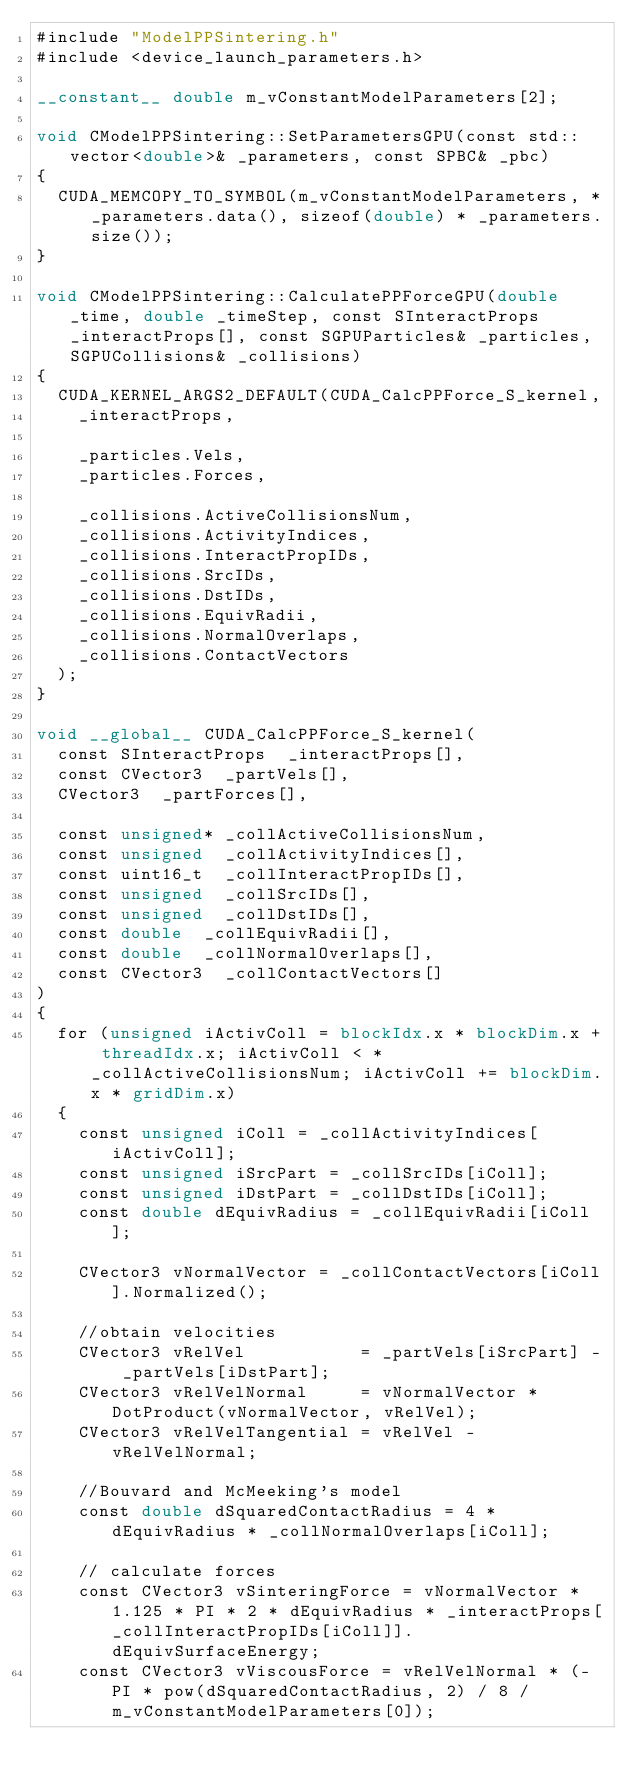Convert code to text. <code><loc_0><loc_0><loc_500><loc_500><_Cuda_>#include "ModelPPSintering.h"
#include <device_launch_parameters.h>

__constant__ double m_vConstantModelParameters[2];

void CModelPPSintering::SetParametersGPU(const std::vector<double>& _parameters, const SPBC& _pbc)
{
	CUDA_MEMCOPY_TO_SYMBOL(m_vConstantModelParameters, *_parameters.data(), sizeof(double) * _parameters.size());
}

void CModelPPSintering::CalculatePPForceGPU(double _time, double _timeStep, const SInteractProps _interactProps[], const SGPUParticles& _particles, SGPUCollisions& _collisions)
{
	CUDA_KERNEL_ARGS2_DEFAULT(CUDA_CalcPPForce_S_kernel,
		_interactProps,

		_particles.Vels,
		_particles.Forces,

		_collisions.ActiveCollisionsNum,
		_collisions.ActivityIndices,
		_collisions.InteractPropIDs,
		_collisions.SrcIDs,
		_collisions.DstIDs,
		_collisions.EquivRadii,
		_collisions.NormalOverlaps,
		_collisions.ContactVectors
	);
}

void __global__ CUDA_CalcPPForce_S_kernel(
	const SInteractProps	_interactProps[],
	const CVector3	_partVels[],
	CVector3	_partForces[],

	const unsigned*	_collActiveCollisionsNum,
	const unsigned	_collActivityIndices[],
	const uint16_t	_collInteractPropIDs[],
	const unsigned	_collSrcIDs[],
	const unsigned	_collDstIDs[],
	const double	_collEquivRadii[],
	const double	_collNormalOverlaps[],
	const CVector3  _collContactVectors[]
)
{
	for (unsigned iActivColl = blockIdx.x * blockDim.x + threadIdx.x; iActivColl < *_collActiveCollisionsNum; iActivColl += blockDim.x * gridDim.x)
	{
		const unsigned iColl = _collActivityIndices[iActivColl];
		const unsigned iSrcPart = _collSrcIDs[iColl];
		const unsigned iDstPart = _collDstIDs[iColl];
		const double dEquivRadius = _collEquivRadii[iColl];

		CVector3 vNormalVector = _collContactVectors[iColl].Normalized();

		//obtain velocities
		CVector3 vRelVel           = _partVels[iSrcPart] - _partVels[iDstPart];
		CVector3 vRelVelNormal     = vNormalVector * DotProduct(vNormalVector, vRelVel);
		CVector3 vRelVelTangential = vRelVel - vRelVelNormal;

		//Bouvard and McMeeking's model
		const double dSquaredContactRadius = 4 * dEquivRadius * _collNormalOverlaps[iColl];

		// calculate forces
		const CVector3 vSinteringForce = vNormalVector * 1.125 * PI * 2 * dEquivRadius * _interactProps[_collInteractPropIDs[iColl]].dEquivSurfaceEnergy;
		const CVector3 vViscousForce = vRelVelNormal * (-PI * pow(dSquaredContactRadius, 2) / 8 / m_vConstantModelParameters[0]);</code> 